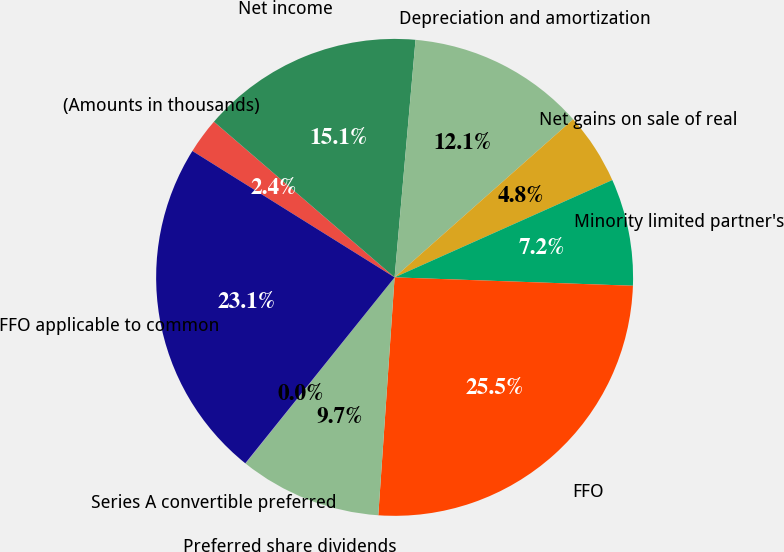<chart> <loc_0><loc_0><loc_500><loc_500><pie_chart><fcel>(Amounts in thousands)<fcel>Net income<fcel>Depreciation and amortization<fcel>Net gains on sale of real<fcel>Minority limited partner's<fcel>FFO<fcel>Preferred share dividends<fcel>Series A convertible preferred<fcel>FFO applicable to common<nl><fcel>2.43%<fcel>15.08%<fcel>12.07%<fcel>4.84%<fcel>7.25%<fcel>25.53%<fcel>9.66%<fcel>0.02%<fcel>23.12%<nl></chart> 